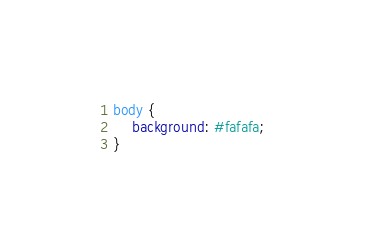<code> <loc_0><loc_0><loc_500><loc_500><_CSS_>body {
    background: #fafafa;
}</code> 